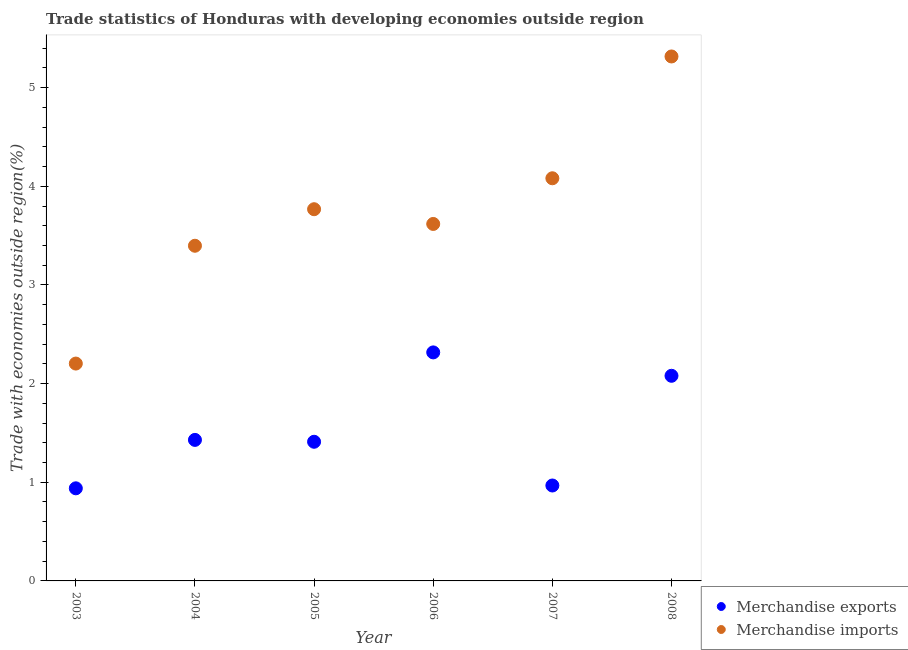How many different coloured dotlines are there?
Your answer should be very brief. 2. What is the merchandise exports in 2003?
Make the answer very short. 0.94. Across all years, what is the maximum merchandise exports?
Ensure brevity in your answer.  2.32. Across all years, what is the minimum merchandise exports?
Keep it short and to the point. 0.94. What is the total merchandise imports in the graph?
Give a very brief answer. 22.38. What is the difference between the merchandise exports in 2005 and that in 2008?
Ensure brevity in your answer.  -0.67. What is the difference between the merchandise imports in 2006 and the merchandise exports in 2004?
Provide a short and direct response. 2.19. What is the average merchandise imports per year?
Offer a very short reply. 3.73. In the year 2008, what is the difference between the merchandise exports and merchandise imports?
Provide a succinct answer. -3.24. In how many years, is the merchandise imports greater than 2.2 %?
Your answer should be very brief. 6. What is the ratio of the merchandise exports in 2006 to that in 2008?
Make the answer very short. 1.11. Is the merchandise exports in 2004 less than that in 2005?
Provide a succinct answer. No. Is the difference between the merchandise exports in 2003 and 2006 greater than the difference between the merchandise imports in 2003 and 2006?
Keep it short and to the point. Yes. What is the difference between the highest and the second highest merchandise imports?
Your response must be concise. 1.23. What is the difference between the highest and the lowest merchandise exports?
Ensure brevity in your answer.  1.38. Is the merchandise imports strictly greater than the merchandise exports over the years?
Your answer should be very brief. Yes. Is the merchandise imports strictly less than the merchandise exports over the years?
Offer a terse response. No. How many dotlines are there?
Ensure brevity in your answer.  2. How many years are there in the graph?
Offer a very short reply. 6. Are the values on the major ticks of Y-axis written in scientific E-notation?
Ensure brevity in your answer.  No. What is the title of the graph?
Your answer should be compact. Trade statistics of Honduras with developing economies outside region. What is the label or title of the X-axis?
Your answer should be compact. Year. What is the label or title of the Y-axis?
Your answer should be compact. Trade with economies outside region(%). What is the Trade with economies outside region(%) in Merchandise exports in 2003?
Provide a short and direct response. 0.94. What is the Trade with economies outside region(%) in Merchandise imports in 2003?
Make the answer very short. 2.2. What is the Trade with economies outside region(%) of Merchandise exports in 2004?
Provide a succinct answer. 1.43. What is the Trade with economies outside region(%) of Merchandise imports in 2004?
Provide a succinct answer. 3.4. What is the Trade with economies outside region(%) of Merchandise exports in 2005?
Keep it short and to the point. 1.41. What is the Trade with economies outside region(%) of Merchandise imports in 2005?
Make the answer very short. 3.77. What is the Trade with economies outside region(%) of Merchandise exports in 2006?
Give a very brief answer. 2.32. What is the Trade with economies outside region(%) in Merchandise imports in 2006?
Keep it short and to the point. 3.62. What is the Trade with economies outside region(%) in Merchandise exports in 2007?
Make the answer very short. 0.97. What is the Trade with economies outside region(%) of Merchandise imports in 2007?
Ensure brevity in your answer.  4.08. What is the Trade with economies outside region(%) of Merchandise exports in 2008?
Keep it short and to the point. 2.08. What is the Trade with economies outside region(%) in Merchandise imports in 2008?
Your answer should be compact. 5.32. Across all years, what is the maximum Trade with economies outside region(%) in Merchandise exports?
Make the answer very short. 2.32. Across all years, what is the maximum Trade with economies outside region(%) in Merchandise imports?
Provide a succinct answer. 5.32. Across all years, what is the minimum Trade with economies outside region(%) in Merchandise exports?
Provide a succinct answer. 0.94. Across all years, what is the minimum Trade with economies outside region(%) of Merchandise imports?
Provide a short and direct response. 2.2. What is the total Trade with economies outside region(%) in Merchandise exports in the graph?
Ensure brevity in your answer.  9.14. What is the total Trade with economies outside region(%) in Merchandise imports in the graph?
Your answer should be very brief. 22.38. What is the difference between the Trade with economies outside region(%) of Merchandise exports in 2003 and that in 2004?
Your answer should be compact. -0.49. What is the difference between the Trade with economies outside region(%) of Merchandise imports in 2003 and that in 2004?
Ensure brevity in your answer.  -1.19. What is the difference between the Trade with economies outside region(%) in Merchandise exports in 2003 and that in 2005?
Ensure brevity in your answer.  -0.47. What is the difference between the Trade with economies outside region(%) in Merchandise imports in 2003 and that in 2005?
Offer a very short reply. -1.56. What is the difference between the Trade with economies outside region(%) in Merchandise exports in 2003 and that in 2006?
Your response must be concise. -1.38. What is the difference between the Trade with economies outside region(%) of Merchandise imports in 2003 and that in 2006?
Keep it short and to the point. -1.42. What is the difference between the Trade with economies outside region(%) in Merchandise exports in 2003 and that in 2007?
Make the answer very short. -0.03. What is the difference between the Trade with economies outside region(%) of Merchandise imports in 2003 and that in 2007?
Your answer should be compact. -1.88. What is the difference between the Trade with economies outside region(%) in Merchandise exports in 2003 and that in 2008?
Keep it short and to the point. -1.14. What is the difference between the Trade with economies outside region(%) in Merchandise imports in 2003 and that in 2008?
Make the answer very short. -3.11. What is the difference between the Trade with economies outside region(%) in Merchandise exports in 2004 and that in 2005?
Your answer should be compact. 0.02. What is the difference between the Trade with economies outside region(%) in Merchandise imports in 2004 and that in 2005?
Provide a succinct answer. -0.37. What is the difference between the Trade with economies outside region(%) of Merchandise exports in 2004 and that in 2006?
Your answer should be very brief. -0.89. What is the difference between the Trade with economies outside region(%) of Merchandise imports in 2004 and that in 2006?
Your answer should be compact. -0.22. What is the difference between the Trade with economies outside region(%) in Merchandise exports in 2004 and that in 2007?
Your response must be concise. 0.46. What is the difference between the Trade with economies outside region(%) of Merchandise imports in 2004 and that in 2007?
Offer a very short reply. -0.68. What is the difference between the Trade with economies outside region(%) in Merchandise exports in 2004 and that in 2008?
Provide a short and direct response. -0.65. What is the difference between the Trade with economies outside region(%) in Merchandise imports in 2004 and that in 2008?
Provide a succinct answer. -1.92. What is the difference between the Trade with economies outside region(%) of Merchandise exports in 2005 and that in 2006?
Keep it short and to the point. -0.91. What is the difference between the Trade with economies outside region(%) of Merchandise imports in 2005 and that in 2006?
Offer a terse response. 0.15. What is the difference between the Trade with economies outside region(%) of Merchandise exports in 2005 and that in 2007?
Make the answer very short. 0.44. What is the difference between the Trade with economies outside region(%) in Merchandise imports in 2005 and that in 2007?
Offer a terse response. -0.31. What is the difference between the Trade with economies outside region(%) of Merchandise exports in 2005 and that in 2008?
Provide a short and direct response. -0.67. What is the difference between the Trade with economies outside region(%) of Merchandise imports in 2005 and that in 2008?
Ensure brevity in your answer.  -1.55. What is the difference between the Trade with economies outside region(%) in Merchandise exports in 2006 and that in 2007?
Ensure brevity in your answer.  1.35. What is the difference between the Trade with economies outside region(%) of Merchandise imports in 2006 and that in 2007?
Ensure brevity in your answer.  -0.46. What is the difference between the Trade with economies outside region(%) in Merchandise exports in 2006 and that in 2008?
Provide a short and direct response. 0.24. What is the difference between the Trade with economies outside region(%) of Merchandise imports in 2006 and that in 2008?
Ensure brevity in your answer.  -1.7. What is the difference between the Trade with economies outside region(%) of Merchandise exports in 2007 and that in 2008?
Offer a very short reply. -1.11. What is the difference between the Trade with economies outside region(%) in Merchandise imports in 2007 and that in 2008?
Offer a very short reply. -1.23. What is the difference between the Trade with economies outside region(%) in Merchandise exports in 2003 and the Trade with economies outside region(%) in Merchandise imports in 2004?
Make the answer very short. -2.46. What is the difference between the Trade with economies outside region(%) of Merchandise exports in 2003 and the Trade with economies outside region(%) of Merchandise imports in 2005?
Your answer should be compact. -2.83. What is the difference between the Trade with economies outside region(%) in Merchandise exports in 2003 and the Trade with economies outside region(%) in Merchandise imports in 2006?
Your response must be concise. -2.68. What is the difference between the Trade with economies outside region(%) of Merchandise exports in 2003 and the Trade with economies outside region(%) of Merchandise imports in 2007?
Keep it short and to the point. -3.14. What is the difference between the Trade with economies outside region(%) in Merchandise exports in 2003 and the Trade with economies outside region(%) in Merchandise imports in 2008?
Make the answer very short. -4.38. What is the difference between the Trade with economies outside region(%) in Merchandise exports in 2004 and the Trade with economies outside region(%) in Merchandise imports in 2005?
Your answer should be very brief. -2.34. What is the difference between the Trade with economies outside region(%) in Merchandise exports in 2004 and the Trade with economies outside region(%) in Merchandise imports in 2006?
Provide a short and direct response. -2.19. What is the difference between the Trade with economies outside region(%) in Merchandise exports in 2004 and the Trade with economies outside region(%) in Merchandise imports in 2007?
Provide a short and direct response. -2.65. What is the difference between the Trade with economies outside region(%) in Merchandise exports in 2004 and the Trade with economies outside region(%) in Merchandise imports in 2008?
Your answer should be compact. -3.89. What is the difference between the Trade with economies outside region(%) in Merchandise exports in 2005 and the Trade with economies outside region(%) in Merchandise imports in 2006?
Your answer should be compact. -2.21. What is the difference between the Trade with economies outside region(%) of Merchandise exports in 2005 and the Trade with economies outside region(%) of Merchandise imports in 2007?
Offer a terse response. -2.67. What is the difference between the Trade with economies outside region(%) of Merchandise exports in 2005 and the Trade with economies outside region(%) of Merchandise imports in 2008?
Your answer should be compact. -3.91. What is the difference between the Trade with economies outside region(%) in Merchandise exports in 2006 and the Trade with economies outside region(%) in Merchandise imports in 2007?
Give a very brief answer. -1.76. What is the difference between the Trade with economies outside region(%) in Merchandise exports in 2006 and the Trade with economies outside region(%) in Merchandise imports in 2008?
Your answer should be compact. -3. What is the difference between the Trade with economies outside region(%) of Merchandise exports in 2007 and the Trade with economies outside region(%) of Merchandise imports in 2008?
Provide a succinct answer. -4.35. What is the average Trade with economies outside region(%) of Merchandise exports per year?
Offer a terse response. 1.52. What is the average Trade with economies outside region(%) in Merchandise imports per year?
Keep it short and to the point. 3.73. In the year 2003, what is the difference between the Trade with economies outside region(%) of Merchandise exports and Trade with economies outside region(%) of Merchandise imports?
Make the answer very short. -1.26. In the year 2004, what is the difference between the Trade with economies outside region(%) in Merchandise exports and Trade with economies outside region(%) in Merchandise imports?
Your answer should be compact. -1.97. In the year 2005, what is the difference between the Trade with economies outside region(%) of Merchandise exports and Trade with economies outside region(%) of Merchandise imports?
Provide a succinct answer. -2.36. In the year 2006, what is the difference between the Trade with economies outside region(%) in Merchandise exports and Trade with economies outside region(%) in Merchandise imports?
Your answer should be compact. -1.3. In the year 2007, what is the difference between the Trade with economies outside region(%) in Merchandise exports and Trade with economies outside region(%) in Merchandise imports?
Keep it short and to the point. -3.11. In the year 2008, what is the difference between the Trade with economies outside region(%) of Merchandise exports and Trade with economies outside region(%) of Merchandise imports?
Provide a short and direct response. -3.24. What is the ratio of the Trade with economies outside region(%) of Merchandise exports in 2003 to that in 2004?
Your answer should be compact. 0.66. What is the ratio of the Trade with economies outside region(%) in Merchandise imports in 2003 to that in 2004?
Offer a terse response. 0.65. What is the ratio of the Trade with economies outside region(%) in Merchandise exports in 2003 to that in 2005?
Your response must be concise. 0.67. What is the ratio of the Trade with economies outside region(%) in Merchandise imports in 2003 to that in 2005?
Provide a short and direct response. 0.58. What is the ratio of the Trade with economies outside region(%) in Merchandise exports in 2003 to that in 2006?
Ensure brevity in your answer.  0.41. What is the ratio of the Trade with economies outside region(%) in Merchandise imports in 2003 to that in 2006?
Provide a succinct answer. 0.61. What is the ratio of the Trade with economies outside region(%) in Merchandise exports in 2003 to that in 2007?
Your answer should be very brief. 0.97. What is the ratio of the Trade with economies outside region(%) in Merchandise imports in 2003 to that in 2007?
Offer a terse response. 0.54. What is the ratio of the Trade with economies outside region(%) in Merchandise exports in 2003 to that in 2008?
Your answer should be compact. 0.45. What is the ratio of the Trade with economies outside region(%) in Merchandise imports in 2003 to that in 2008?
Your answer should be compact. 0.41. What is the ratio of the Trade with economies outside region(%) of Merchandise exports in 2004 to that in 2005?
Provide a short and direct response. 1.01. What is the ratio of the Trade with economies outside region(%) in Merchandise imports in 2004 to that in 2005?
Keep it short and to the point. 0.9. What is the ratio of the Trade with economies outside region(%) in Merchandise exports in 2004 to that in 2006?
Keep it short and to the point. 0.62. What is the ratio of the Trade with economies outside region(%) of Merchandise imports in 2004 to that in 2006?
Give a very brief answer. 0.94. What is the ratio of the Trade with economies outside region(%) of Merchandise exports in 2004 to that in 2007?
Your answer should be very brief. 1.48. What is the ratio of the Trade with economies outside region(%) in Merchandise imports in 2004 to that in 2007?
Ensure brevity in your answer.  0.83. What is the ratio of the Trade with economies outside region(%) in Merchandise exports in 2004 to that in 2008?
Ensure brevity in your answer.  0.69. What is the ratio of the Trade with economies outside region(%) of Merchandise imports in 2004 to that in 2008?
Your answer should be compact. 0.64. What is the ratio of the Trade with economies outside region(%) of Merchandise exports in 2005 to that in 2006?
Ensure brevity in your answer.  0.61. What is the ratio of the Trade with economies outside region(%) in Merchandise imports in 2005 to that in 2006?
Provide a short and direct response. 1.04. What is the ratio of the Trade with economies outside region(%) in Merchandise exports in 2005 to that in 2007?
Offer a very short reply. 1.46. What is the ratio of the Trade with economies outside region(%) in Merchandise imports in 2005 to that in 2007?
Make the answer very short. 0.92. What is the ratio of the Trade with economies outside region(%) in Merchandise exports in 2005 to that in 2008?
Keep it short and to the point. 0.68. What is the ratio of the Trade with economies outside region(%) in Merchandise imports in 2005 to that in 2008?
Offer a very short reply. 0.71. What is the ratio of the Trade with economies outside region(%) in Merchandise exports in 2006 to that in 2007?
Provide a short and direct response. 2.39. What is the ratio of the Trade with economies outside region(%) of Merchandise imports in 2006 to that in 2007?
Keep it short and to the point. 0.89. What is the ratio of the Trade with economies outside region(%) in Merchandise exports in 2006 to that in 2008?
Offer a terse response. 1.11. What is the ratio of the Trade with economies outside region(%) in Merchandise imports in 2006 to that in 2008?
Offer a terse response. 0.68. What is the ratio of the Trade with economies outside region(%) of Merchandise exports in 2007 to that in 2008?
Provide a succinct answer. 0.47. What is the ratio of the Trade with economies outside region(%) in Merchandise imports in 2007 to that in 2008?
Ensure brevity in your answer.  0.77. What is the difference between the highest and the second highest Trade with economies outside region(%) in Merchandise exports?
Your answer should be compact. 0.24. What is the difference between the highest and the second highest Trade with economies outside region(%) of Merchandise imports?
Make the answer very short. 1.23. What is the difference between the highest and the lowest Trade with economies outside region(%) in Merchandise exports?
Your answer should be very brief. 1.38. What is the difference between the highest and the lowest Trade with economies outside region(%) of Merchandise imports?
Offer a very short reply. 3.11. 